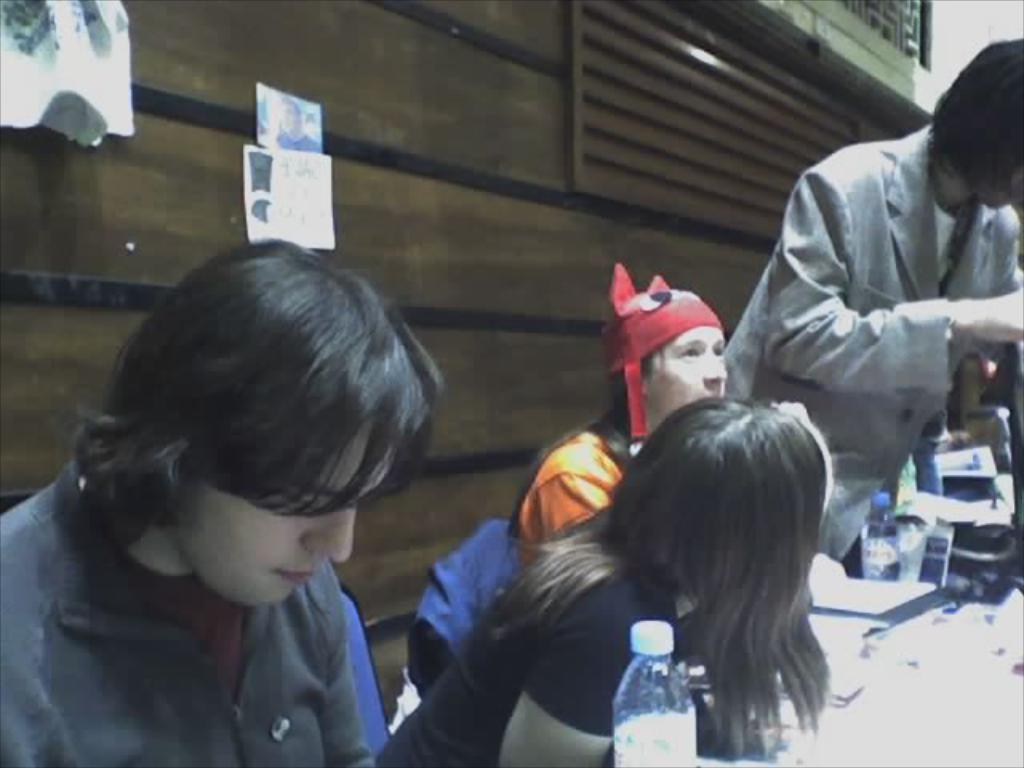Describe this image in one or two sentences. In this picture i could see four persons sitting on the table and doing there work. In the back ground there is a wooden planks and on the table there is some papers bottles and some other stuff. 